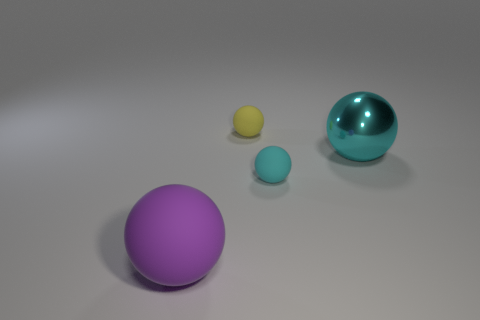What are possible uses for these objects? These spheres could represent a variety of objects, from simple geometric forms used in a 3D modeling software demonstration to conceptual art pieces. In a practical sense, they could be decorative items or even part of a child's playset, given their various sizes and colors. 